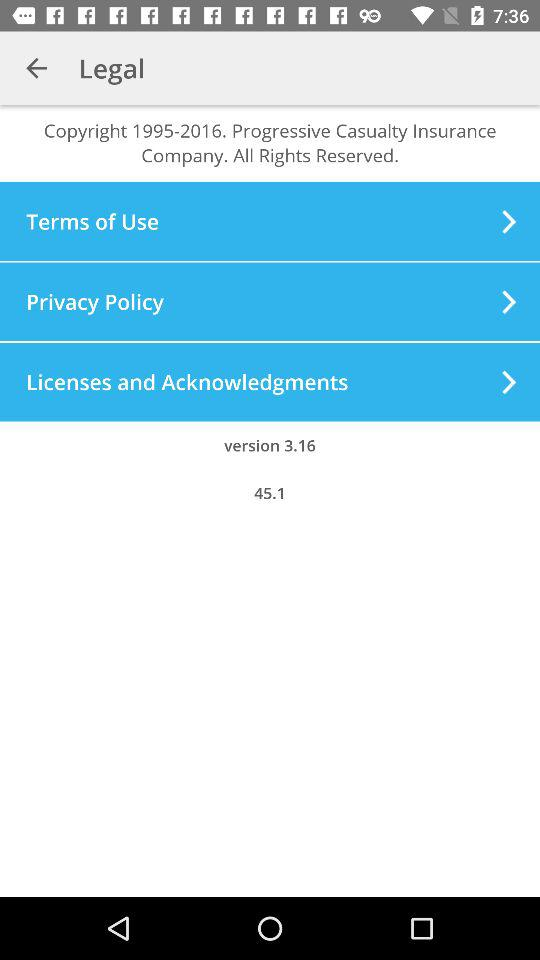What is the version number of the software?
Answer the question using a single word or phrase. 3.16 